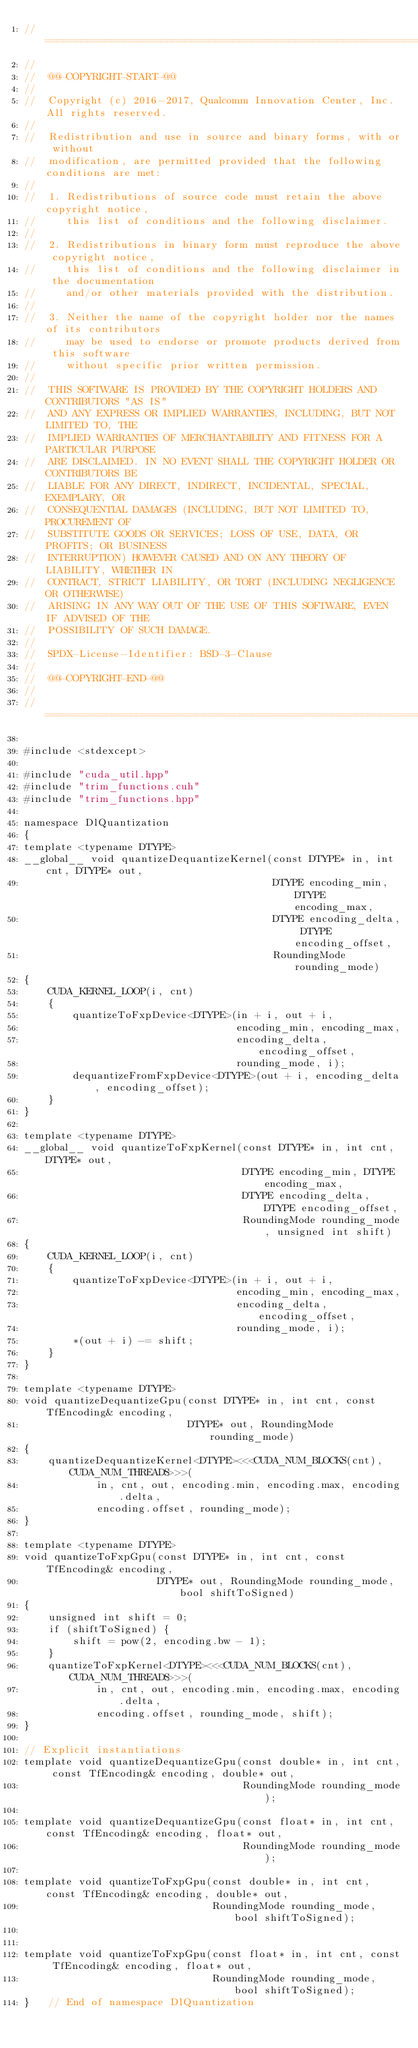<code> <loc_0><loc_0><loc_500><loc_500><_Cuda_>//==============================================================================
//
//  @@-COPYRIGHT-START-@@
//
//  Copyright (c) 2016-2017, Qualcomm Innovation Center, Inc. All rights reserved.
//
//  Redistribution and use in source and binary forms, with or without
//  modification, are permitted provided that the following conditions are met:
//
//  1. Redistributions of source code must retain the above copyright notice,
//     this list of conditions and the following disclaimer.
//
//  2. Redistributions in binary form must reproduce the above copyright notice,
//     this list of conditions and the following disclaimer in the documentation
//     and/or other materials provided with the distribution.
//
//  3. Neither the name of the copyright holder nor the names of its contributors
//     may be used to endorse or promote products derived from this software
//     without specific prior written permission.
//
//  THIS SOFTWARE IS PROVIDED BY THE COPYRIGHT HOLDERS AND CONTRIBUTORS "AS IS"
//  AND ANY EXPRESS OR IMPLIED WARRANTIES, INCLUDING, BUT NOT LIMITED TO, THE
//  IMPLIED WARRANTIES OF MERCHANTABILITY AND FITNESS FOR A PARTICULAR PURPOSE
//  ARE DISCLAIMED. IN NO EVENT SHALL THE COPYRIGHT HOLDER OR CONTRIBUTORS BE
//  LIABLE FOR ANY DIRECT, INDIRECT, INCIDENTAL, SPECIAL, EXEMPLARY, OR
//  CONSEQUENTIAL DAMAGES (INCLUDING, BUT NOT LIMITED TO, PROCUREMENT OF
//  SUBSTITUTE GOODS OR SERVICES; LOSS OF USE, DATA, OR PROFITS; OR BUSINESS
//  INTERRUPTION) HOWEVER CAUSED AND ON ANY THEORY OF LIABILITY, WHETHER IN
//  CONTRACT, STRICT LIABILITY, OR TORT (INCLUDING NEGLIGENCE OR OTHERWISE)
//  ARISING IN ANY WAY OUT OF THE USE OF THIS SOFTWARE, EVEN IF ADVISED OF THE
//  POSSIBILITY OF SUCH DAMAGE.
//
//  SPDX-License-Identifier: BSD-3-Clause
//
//  @@-COPYRIGHT-END-@@
//
//==============================================================================

#include <stdexcept>

#include "cuda_util.hpp"
#include "trim_functions.cuh"
#include "trim_functions.hpp"

namespace DlQuantization
{
template <typename DTYPE>
__global__ void quantizeDequantizeKernel(const DTYPE* in, int cnt, DTYPE* out,
                                         DTYPE encoding_min, DTYPE encoding_max,
                                         DTYPE encoding_delta, DTYPE encoding_offset,
                                         RoundingMode rounding_mode)
{
    CUDA_KERNEL_LOOP(i, cnt)
    {
        quantizeToFxpDevice<DTYPE>(in + i, out + i,
                                   encoding_min, encoding_max,
                                   encoding_delta, encoding_offset,
                                   rounding_mode, i);
        dequantizeFromFxpDevice<DTYPE>(out + i, encoding_delta, encoding_offset);
    }
}

template <typename DTYPE>
__global__ void quantizeToFxpKernel(const DTYPE* in, int cnt, DTYPE* out,
                                    DTYPE encoding_min, DTYPE encoding_max,
                                    DTYPE encoding_delta, DTYPE encoding_offset,
                                    RoundingMode rounding_mode, unsigned int shift)
{
    CUDA_KERNEL_LOOP(i, cnt)
    {
        quantizeToFxpDevice<DTYPE>(in + i, out + i,
                                   encoding_min, encoding_max,
                                   encoding_delta, encoding_offset,
                                   rounding_mode, i);
        *(out + i) -= shift;
    }
}

template <typename DTYPE>
void quantizeDequantizeGpu(const DTYPE* in, int cnt, const TfEncoding& encoding,
                           DTYPE* out, RoundingMode rounding_mode)
{
    quantizeDequantizeKernel<DTYPE><<<CUDA_NUM_BLOCKS(cnt), CUDA_NUM_THREADS>>>(
            in, cnt, out, encoding.min, encoding.max, encoding.delta,
            encoding.offset, rounding_mode);
}

template <typename DTYPE>
void quantizeToFxpGpu(const DTYPE* in, int cnt, const TfEncoding& encoding,
                      DTYPE* out, RoundingMode rounding_mode, bool shiftToSigned)
{
    unsigned int shift = 0;
    if (shiftToSigned) {
        shift = pow(2, encoding.bw - 1);
    }
    quantizeToFxpKernel<DTYPE><<<CUDA_NUM_BLOCKS(cnt), CUDA_NUM_THREADS>>>(
            in, cnt, out, encoding.min, encoding.max, encoding.delta,
            encoding.offset, rounding_mode, shift);
}

// Explicit instantiations
template void quantizeDequantizeGpu(const double* in, int cnt, const TfEncoding& encoding, double* out,
                                    RoundingMode rounding_mode);

template void quantizeDequantizeGpu(const float* in, int cnt, const TfEncoding& encoding, float* out,
                                    RoundingMode rounding_mode);

template void quantizeToFxpGpu(const double* in, int cnt, const TfEncoding& encoding, double* out,
                               RoundingMode rounding_mode, bool shiftToSigned);


template void quantizeToFxpGpu(const float* in, int cnt, const TfEncoding& encoding, float* out,
                               RoundingMode rounding_mode, bool shiftToSigned);
}   // End of namespace DlQuantization
</code> 